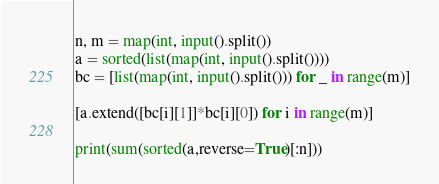Convert code to text. <code><loc_0><loc_0><loc_500><loc_500><_Python_>n, m = map(int, input().split())
a = sorted(list(map(int, input().split())))
bc = [list(map(int, input().split())) for _ in range(m)]

[a.extend([bc[i][1]]*bc[i][0]) for i in range(m)]

print(sum(sorted(a,reverse=True)[:n]))
</code> 